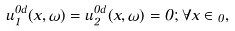<formula> <loc_0><loc_0><loc_500><loc_500>u _ { 1 } ^ { 0 d } ( x , \omega ) = u _ { 2 } ^ { 0 d } ( x , \omega ) = 0 ; \forall x \in \Omega _ { 0 } ,</formula> 